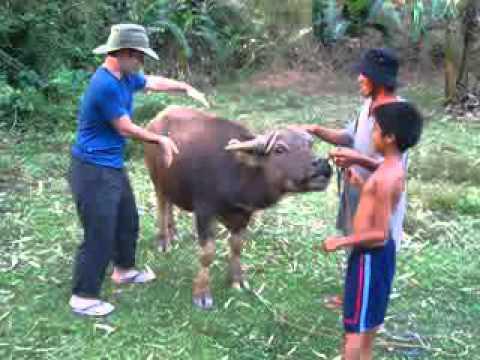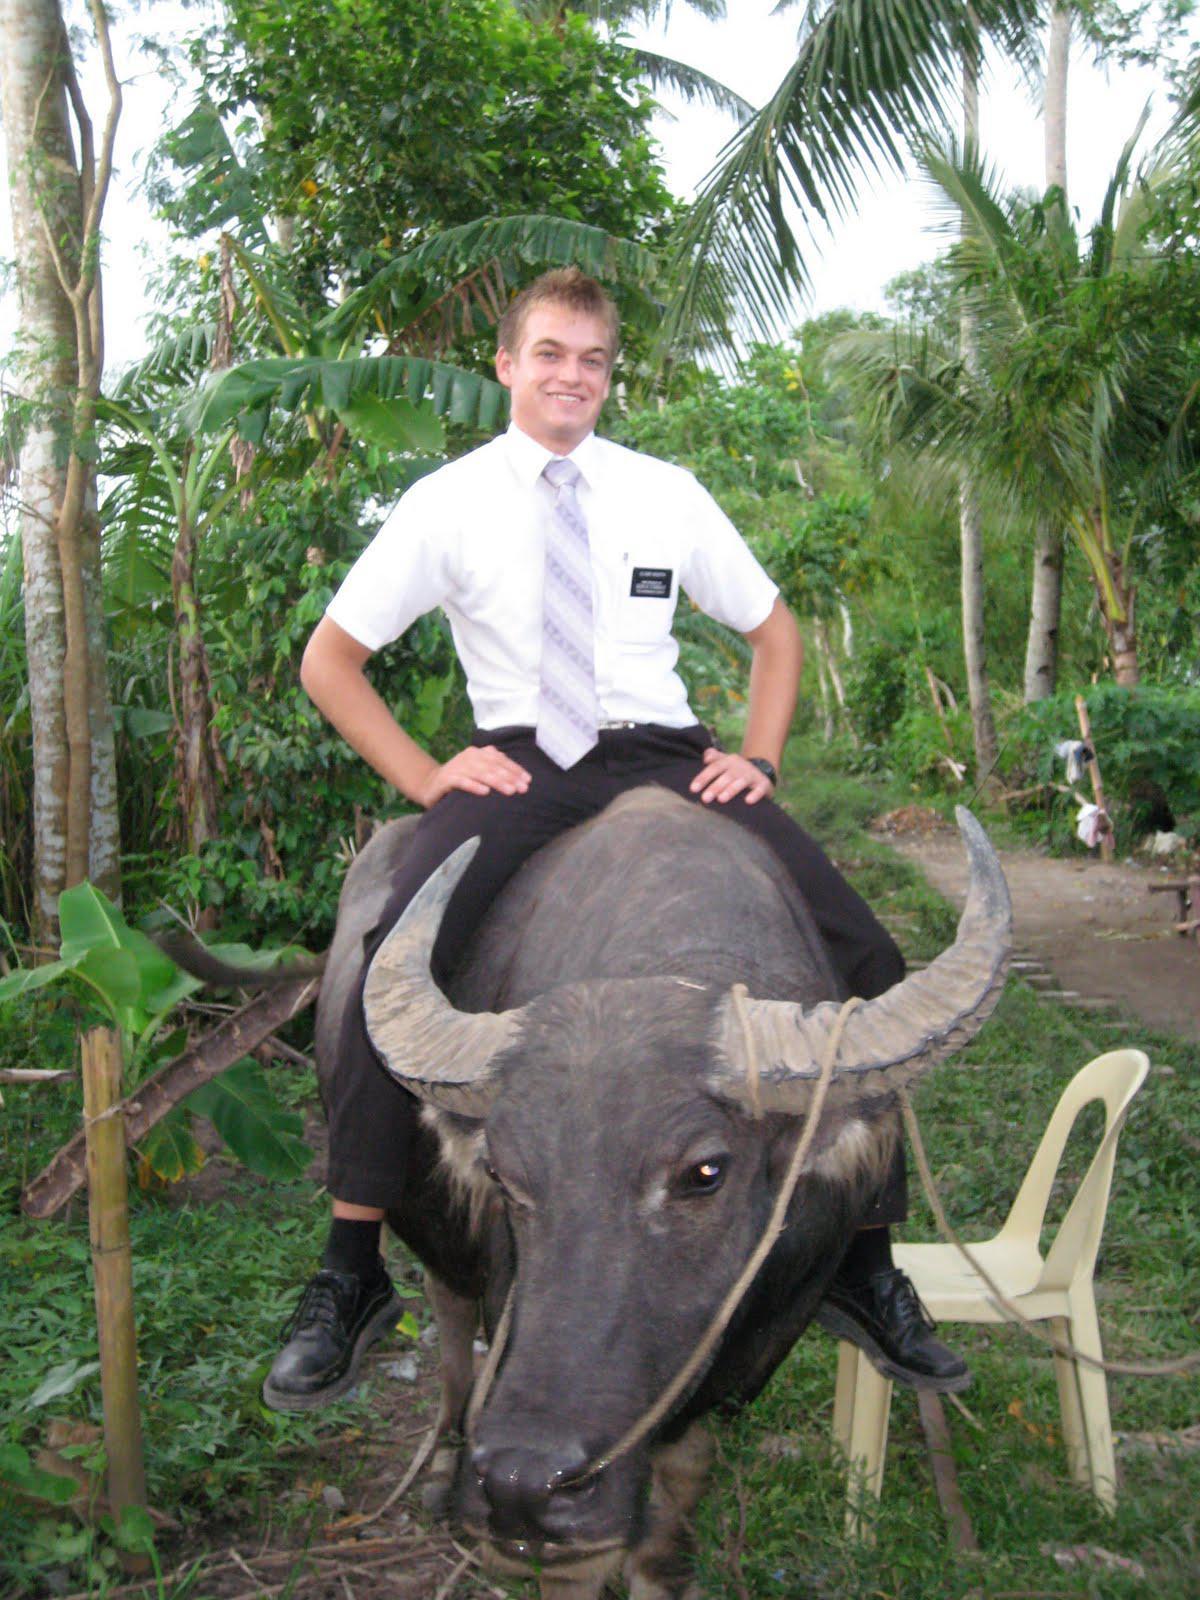The first image is the image on the left, the second image is the image on the right. Assess this claim about the two images: "The right image contains at least two people riding on a water buffalo.". Correct or not? Answer yes or no. No. The first image is the image on the left, the second image is the image on the right. Assess this claim about the two images: "At least one water buffalo is standing in water in the left image.". Correct or not? Answer yes or no. No. 